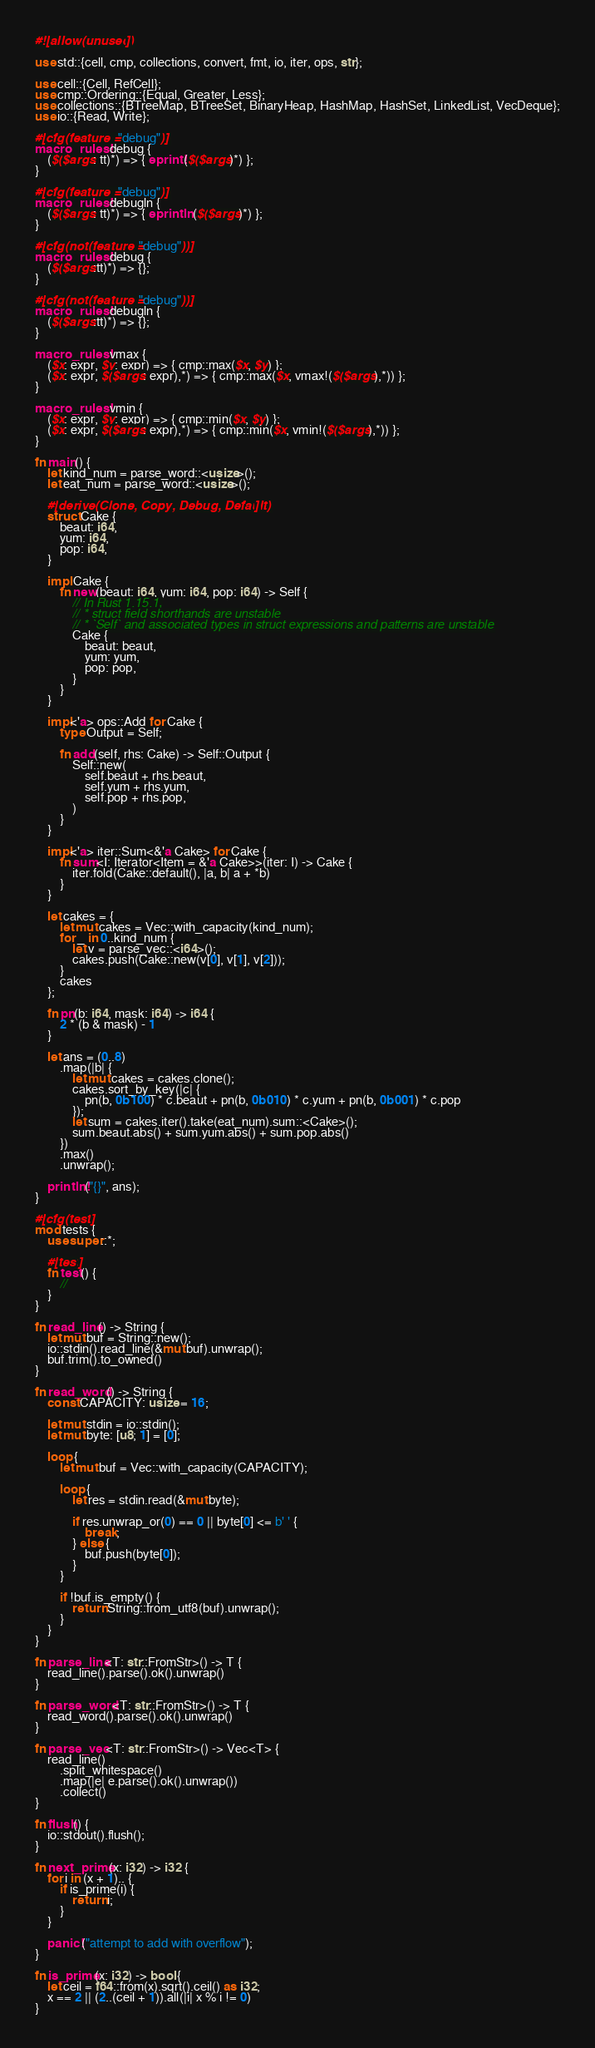Convert code to text. <code><loc_0><loc_0><loc_500><loc_500><_Rust_>#![allow(unused)]

use std::{cell, cmp, collections, convert, fmt, io, iter, ops, str};

use cell::{Cell, RefCell};
use cmp::Ordering::{Equal, Greater, Less};
use collections::{BTreeMap, BTreeSet, BinaryHeap, HashMap, HashSet, LinkedList, VecDeque};
use io::{Read, Write};

#[cfg(feature = "debug")]
macro_rules! debug {
    ($($args: tt)*) => { eprint!($($args)*) };
}

#[cfg(feature = "debug")]
macro_rules! debugln {
    ($($args: tt)*) => { eprintln!($($args)*) };
}

#[cfg(not(feature = "debug"))]
macro_rules! debug {
    ($($args:tt)*) => {};
}

#[cfg(not(feature = "debug"))]
macro_rules! debugln {
    ($($args:tt)*) => {};
}

macro_rules! vmax {
    ($x: expr, $y: expr) => { cmp::max($x, $y) };
    ($x: expr, $($args: expr),*) => { cmp::max($x, vmax!($($args),*)) };
}

macro_rules! vmin {
    ($x: expr, $y: expr) => { cmp::min($x, $y) };
    ($x: expr, $($args: expr),*) => { cmp::min($x, vmin!($($args),*)) };
}

fn main() {
    let kind_num = parse_word::<usize>();
    let eat_num = parse_word::<usize>();

    #[derive(Clone, Copy, Debug, Default)]
    struct Cake {
        beaut: i64,
        yum: i64,
        pop: i64,
    }

    impl Cake {
        fn new(beaut: i64, yum: i64, pop: i64) -> Self {
            // In Rust 1.15.1,
            // * struct field shorthands are unstable
            // * `Self` and associated types in struct expressions and patterns are unstable
            Cake {
                beaut: beaut,
                yum: yum,
                pop: pop,
            }
        }
    }

    impl<'a> ops::Add for Cake {
        type Output = Self;

        fn add(self, rhs: Cake) -> Self::Output {
            Self::new(
                self.beaut + rhs.beaut,
                self.yum + rhs.yum,
                self.pop + rhs.pop,
            )
        }
    }

    impl<'a> iter::Sum<&'a Cake> for Cake {
        fn sum<I: Iterator<Item = &'a Cake>>(iter: I) -> Cake {
            iter.fold(Cake::default(), |a, b| a + *b)
        }
    }

    let cakes = {
        let mut cakes = Vec::with_capacity(kind_num);
        for _ in 0..kind_num {
            let v = parse_vec::<i64>();
            cakes.push(Cake::new(v[0], v[1], v[2]));
        }
        cakes
    };

    fn pn(b: i64, mask: i64) -> i64 {
        2 * (b & mask) - 1
    }

    let ans = (0..8)
        .map(|b| {
            let mut cakes = cakes.clone();
            cakes.sort_by_key(|c| {
                pn(b, 0b100) * c.beaut + pn(b, 0b010) * c.yum + pn(b, 0b001) * c.pop
            });
            let sum = cakes.iter().take(eat_num).sum::<Cake>();
            sum.beaut.abs() + sum.yum.abs() + sum.pop.abs()
        })
        .max()
        .unwrap();

    println!("{}", ans);
}

#[cfg(test)]
mod tests {
    use super::*;

    #[test]
    fn test() {
        //
    }
}

fn read_line() -> String {
    let mut buf = String::new();
    io::stdin().read_line(&mut buf).unwrap();
    buf.trim().to_owned()
}

fn read_word() -> String {
    const CAPACITY: usize = 16;

    let mut stdin = io::stdin();
    let mut byte: [u8; 1] = [0];

    loop {
        let mut buf = Vec::with_capacity(CAPACITY);

        loop {
            let res = stdin.read(&mut byte);

            if res.unwrap_or(0) == 0 || byte[0] <= b' ' {
                break;
            } else {
                buf.push(byte[0]);
            }
        }

        if !buf.is_empty() {
            return String::from_utf8(buf).unwrap();
        }
    }
}

fn parse_line<T: str::FromStr>() -> T {
    read_line().parse().ok().unwrap()
}

fn parse_word<T: str::FromStr>() -> T {
    read_word().parse().ok().unwrap()
}

fn parse_vec<T: str::FromStr>() -> Vec<T> {
    read_line()
        .split_whitespace()
        .map(|e| e.parse().ok().unwrap())
        .collect()
}

fn flush() {
    io::stdout().flush();
}

fn next_prime(x: i32) -> i32 {
    for i in (x + 1).. {
        if is_prime(i) {
            return i;
        }
    }

    panic!("attempt to add with overflow");
}

fn is_prime(x: i32) -> bool {
    let ceil = f64::from(x).sqrt().ceil() as i32;
    x == 2 || (2..(ceil + 1)).all(|i| x % i != 0)
}
</code> 